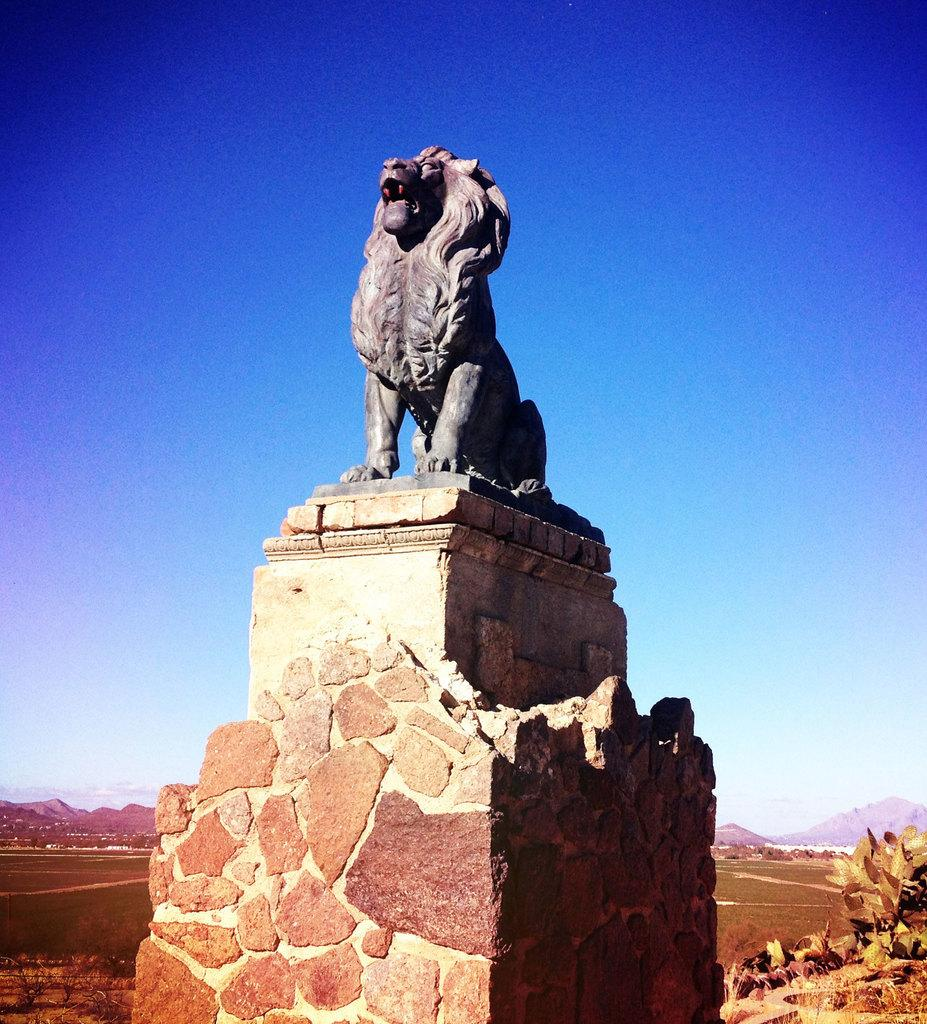What is the main subject in the center of the image? There is a solid structure in the center of the image. What is on top of the solid structure? There is a statue on the solid structure. What can be seen in the background of the image? The sky, hills, plants, and grass are visible in the background of the image. How many beasts can be seen riding bikes in the image? There are no beasts or bikes present in the image. What type of care is being provided to the plants in the image? There is no indication of care being provided to the plants in the image; they are simply visible in the background. 